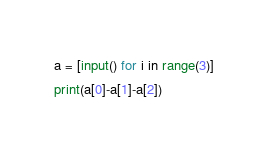Convert code to text. <code><loc_0><loc_0><loc_500><loc_500><_Python_>a = [input() for i in range(3)]
print(a[0]-a[1]-a[2])
</code> 